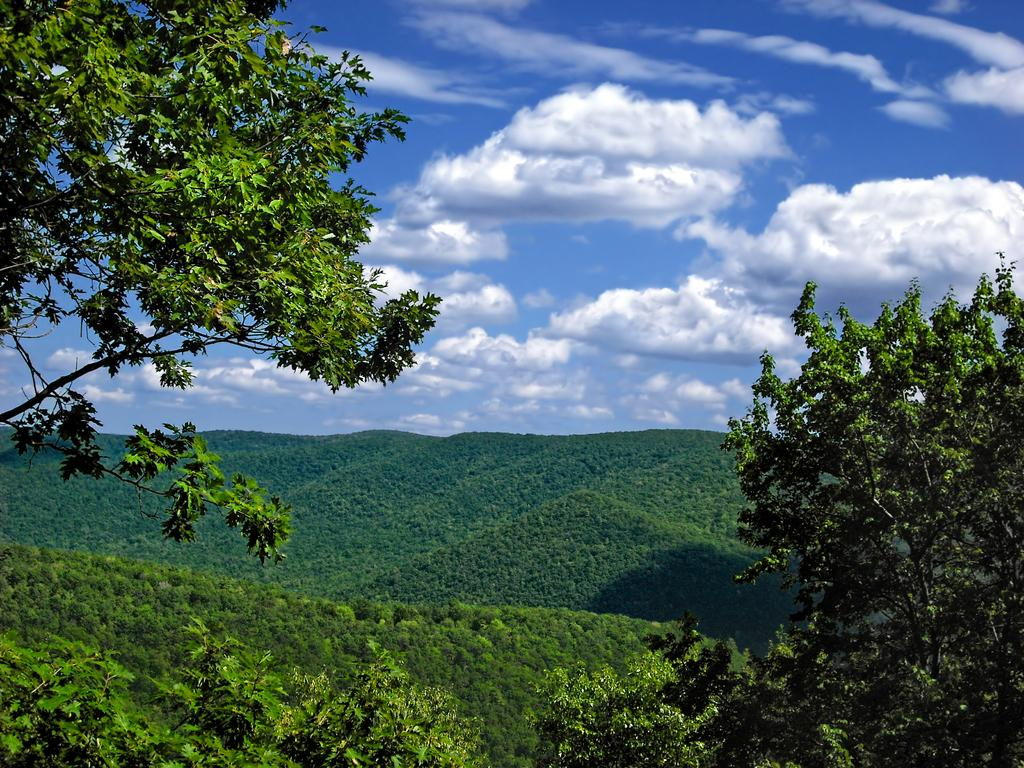What type of vegetation is present in the image? There are trees in the image. What geographical feature can be seen in the image? There is a mountain with grass in the image. What is the condition of the sky in the image? The sky is cloudy in the image. How does the feeling of the coast affect the mountain in the image? There is no coast present in the image, so the feeling of the coast cannot affect the mountain. 